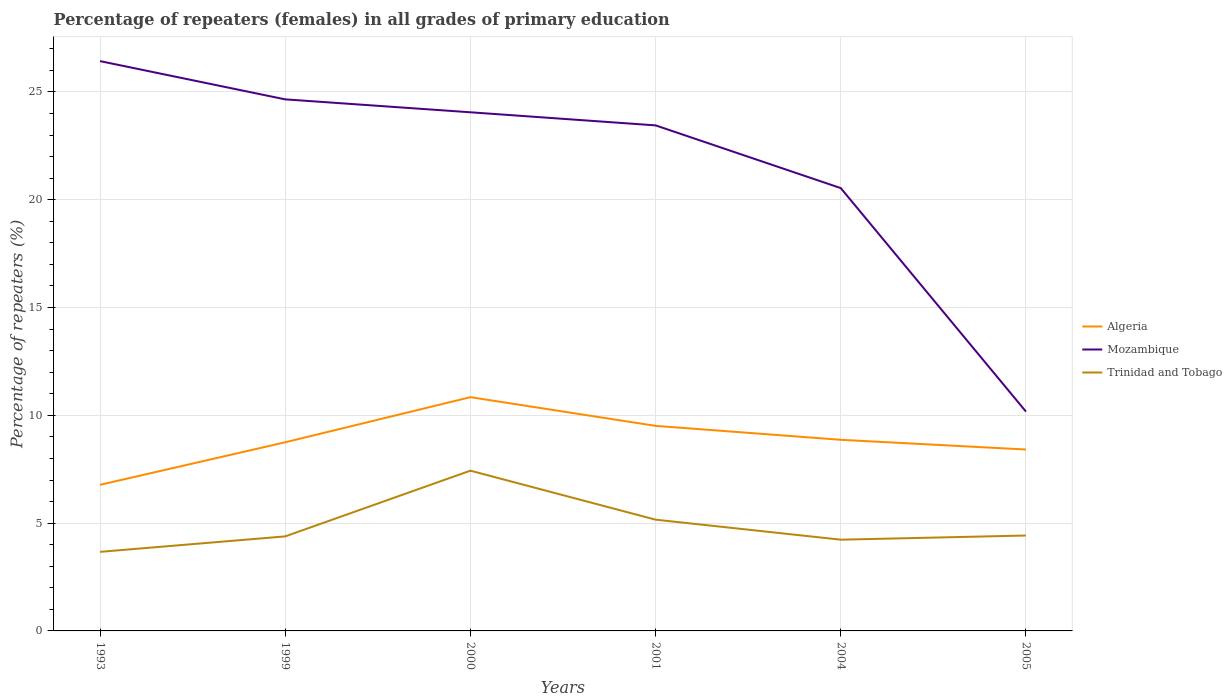Does the line corresponding to Trinidad and Tobago intersect with the line corresponding to Mozambique?
Make the answer very short. No. Is the number of lines equal to the number of legend labels?
Give a very brief answer. Yes. Across all years, what is the maximum percentage of repeaters (females) in Algeria?
Give a very brief answer. 6.78. What is the total percentage of repeaters (females) in Trinidad and Tobago in the graph?
Provide a short and direct response. 0.15. What is the difference between the highest and the second highest percentage of repeaters (females) in Mozambique?
Your answer should be compact. 16.26. What is the difference between the highest and the lowest percentage of repeaters (females) in Algeria?
Make the answer very short. 3. Are the values on the major ticks of Y-axis written in scientific E-notation?
Make the answer very short. No. How are the legend labels stacked?
Provide a succinct answer. Vertical. What is the title of the graph?
Your response must be concise. Percentage of repeaters (females) in all grades of primary education. Does "Angola" appear as one of the legend labels in the graph?
Your answer should be compact. No. What is the label or title of the Y-axis?
Offer a terse response. Percentage of repeaters (%). What is the Percentage of repeaters (%) in Algeria in 1993?
Provide a short and direct response. 6.78. What is the Percentage of repeaters (%) in Mozambique in 1993?
Your response must be concise. 26.43. What is the Percentage of repeaters (%) of Trinidad and Tobago in 1993?
Keep it short and to the point. 3.67. What is the Percentage of repeaters (%) in Algeria in 1999?
Offer a terse response. 8.75. What is the Percentage of repeaters (%) in Mozambique in 1999?
Your answer should be very brief. 24.65. What is the Percentage of repeaters (%) in Trinidad and Tobago in 1999?
Offer a very short reply. 4.38. What is the Percentage of repeaters (%) of Algeria in 2000?
Make the answer very short. 10.84. What is the Percentage of repeaters (%) in Mozambique in 2000?
Your answer should be compact. 24.06. What is the Percentage of repeaters (%) in Trinidad and Tobago in 2000?
Your answer should be very brief. 7.43. What is the Percentage of repeaters (%) in Algeria in 2001?
Your answer should be compact. 9.51. What is the Percentage of repeaters (%) of Mozambique in 2001?
Offer a very short reply. 23.45. What is the Percentage of repeaters (%) in Trinidad and Tobago in 2001?
Offer a very short reply. 5.16. What is the Percentage of repeaters (%) in Algeria in 2004?
Your answer should be compact. 8.86. What is the Percentage of repeaters (%) in Mozambique in 2004?
Ensure brevity in your answer.  20.54. What is the Percentage of repeaters (%) of Trinidad and Tobago in 2004?
Your answer should be compact. 4.23. What is the Percentage of repeaters (%) in Algeria in 2005?
Offer a terse response. 8.41. What is the Percentage of repeaters (%) in Mozambique in 2005?
Your response must be concise. 10.17. What is the Percentage of repeaters (%) of Trinidad and Tobago in 2005?
Your response must be concise. 4.43. Across all years, what is the maximum Percentage of repeaters (%) in Algeria?
Provide a short and direct response. 10.84. Across all years, what is the maximum Percentage of repeaters (%) in Mozambique?
Offer a very short reply. 26.43. Across all years, what is the maximum Percentage of repeaters (%) of Trinidad and Tobago?
Provide a short and direct response. 7.43. Across all years, what is the minimum Percentage of repeaters (%) in Algeria?
Ensure brevity in your answer.  6.78. Across all years, what is the minimum Percentage of repeaters (%) in Mozambique?
Make the answer very short. 10.17. Across all years, what is the minimum Percentage of repeaters (%) in Trinidad and Tobago?
Make the answer very short. 3.67. What is the total Percentage of repeaters (%) of Algeria in the graph?
Offer a very short reply. 53.16. What is the total Percentage of repeaters (%) of Mozambique in the graph?
Your response must be concise. 129.3. What is the total Percentage of repeaters (%) of Trinidad and Tobago in the graph?
Ensure brevity in your answer.  29.3. What is the difference between the Percentage of repeaters (%) of Algeria in 1993 and that in 1999?
Provide a succinct answer. -1.97. What is the difference between the Percentage of repeaters (%) of Mozambique in 1993 and that in 1999?
Offer a very short reply. 1.77. What is the difference between the Percentage of repeaters (%) in Trinidad and Tobago in 1993 and that in 1999?
Keep it short and to the point. -0.72. What is the difference between the Percentage of repeaters (%) of Algeria in 1993 and that in 2000?
Offer a very short reply. -4.07. What is the difference between the Percentage of repeaters (%) of Mozambique in 1993 and that in 2000?
Provide a short and direct response. 2.37. What is the difference between the Percentage of repeaters (%) of Trinidad and Tobago in 1993 and that in 2000?
Give a very brief answer. -3.77. What is the difference between the Percentage of repeaters (%) in Algeria in 1993 and that in 2001?
Offer a very short reply. -2.73. What is the difference between the Percentage of repeaters (%) of Mozambique in 1993 and that in 2001?
Keep it short and to the point. 2.98. What is the difference between the Percentage of repeaters (%) of Trinidad and Tobago in 1993 and that in 2001?
Offer a very short reply. -1.49. What is the difference between the Percentage of repeaters (%) in Algeria in 1993 and that in 2004?
Your answer should be compact. -2.09. What is the difference between the Percentage of repeaters (%) in Mozambique in 1993 and that in 2004?
Your answer should be very brief. 5.89. What is the difference between the Percentage of repeaters (%) in Trinidad and Tobago in 1993 and that in 2004?
Keep it short and to the point. -0.56. What is the difference between the Percentage of repeaters (%) in Algeria in 1993 and that in 2005?
Your answer should be compact. -1.64. What is the difference between the Percentage of repeaters (%) in Mozambique in 1993 and that in 2005?
Offer a terse response. 16.26. What is the difference between the Percentage of repeaters (%) of Trinidad and Tobago in 1993 and that in 2005?
Provide a succinct answer. -0.76. What is the difference between the Percentage of repeaters (%) of Algeria in 1999 and that in 2000?
Give a very brief answer. -2.09. What is the difference between the Percentage of repeaters (%) of Mozambique in 1999 and that in 2000?
Ensure brevity in your answer.  0.6. What is the difference between the Percentage of repeaters (%) in Trinidad and Tobago in 1999 and that in 2000?
Keep it short and to the point. -3.05. What is the difference between the Percentage of repeaters (%) of Algeria in 1999 and that in 2001?
Give a very brief answer. -0.76. What is the difference between the Percentage of repeaters (%) of Mozambique in 1999 and that in 2001?
Ensure brevity in your answer.  1.21. What is the difference between the Percentage of repeaters (%) in Trinidad and Tobago in 1999 and that in 2001?
Your answer should be very brief. -0.78. What is the difference between the Percentage of repeaters (%) in Algeria in 1999 and that in 2004?
Make the answer very short. -0.11. What is the difference between the Percentage of repeaters (%) of Mozambique in 1999 and that in 2004?
Ensure brevity in your answer.  4.12. What is the difference between the Percentage of repeaters (%) in Trinidad and Tobago in 1999 and that in 2004?
Keep it short and to the point. 0.15. What is the difference between the Percentage of repeaters (%) in Algeria in 1999 and that in 2005?
Ensure brevity in your answer.  0.34. What is the difference between the Percentage of repeaters (%) of Mozambique in 1999 and that in 2005?
Provide a short and direct response. 14.48. What is the difference between the Percentage of repeaters (%) in Trinidad and Tobago in 1999 and that in 2005?
Give a very brief answer. -0.04. What is the difference between the Percentage of repeaters (%) in Algeria in 2000 and that in 2001?
Give a very brief answer. 1.33. What is the difference between the Percentage of repeaters (%) in Mozambique in 2000 and that in 2001?
Give a very brief answer. 0.61. What is the difference between the Percentage of repeaters (%) of Trinidad and Tobago in 2000 and that in 2001?
Ensure brevity in your answer.  2.27. What is the difference between the Percentage of repeaters (%) in Algeria in 2000 and that in 2004?
Offer a terse response. 1.98. What is the difference between the Percentage of repeaters (%) of Mozambique in 2000 and that in 2004?
Ensure brevity in your answer.  3.52. What is the difference between the Percentage of repeaters (%) of Trinidad and Tobago in 2000 and that in 2004?
Ensure brevity in your answer.  3.2. What is the difference between the Percentage of repeaters (%) of Algeria in 2000 and that in 2005?
Keep it short and to the point. 2.43. What is the difference between the Percentage of repeaters (%) in Mozambique in 2000 and that in 2005?
Your answer should be very brief. 13.88. What is the difference between the Percentage of repeaters (%) of Trinidad and Tobago in 2000 and that in 2005?
Offer a terse response. 3.01. What is the difference between the Percentage of repeaters (%) of Algeria in 2001 and that in 2004?
Your response must be concise. 0.65. What is the difference between the Percentage of repeaters (%) of Mozambique in 2001 and that in 2004?
Your answer should be very brief. 2.91. What is the difference between the Percentage of repeaters (%) of Trinidad and Tobago in 2001 and that in 2004?
Your response must be concise. 0.93. What is the difference between the Percentage of repeaters (%) of Algeria in 2001 and that in 2005?
Provide a short and direct response. 1.1. What is the difference between the Percentage of repeaters (%) of Mozambique in 2001 and that in 2005?
Your answer should be compact. 13.28. What is the difference between the Percentage of repeaters (%) of Trinidad and Tobago in 2001 and that in 2005?
Provide a succinct answer. 0.73. What is the difference between the Percentage of repeaters (%) in Algeria in 2004 and that in 2005?
Your response must be concise. 0.45. What is the difference between the Percentage of repeaters (%) in Mozambique in 2004 and that in 2005?
Your answer should be very brief. 10.37. What is the difference between the Percentage of repeaters (%) of Trinidad and Tobago in 2004 and that in 2005?
Provide a short and direct response. -0.19. What is the difference between the Percentage of repeaters (%) of Algeria in 1993 and the Percentage of repeaters (%) of Mozambique in 1999?
Your answer should be very brief. -17.88. What is the difference between the Percentage of repeaters (%) of Algeria in 1993 and the Percentage of repeaters (%) of Trinidad and Tobago in 1999?
Ensure brevity in your answer.  2.39. What is the difference between the Percentage of repeaters (%) of Mozambique in 1993 and the Percentage of repeaters (%) of Trinidad and Tobago in 1999?
Keep it short and to the point. 22.04. What is the difference between the Percentage of repeaters (%) in Algeria in 1993 and the Percentage of repeaters (%) in Mozambique in 2000?
Your response must be concise. -17.28. What is the difference between the Percentage of repeaters (%) of Algeria in 1993 and the Percentage of repeaters (%) of Trinidad and Tobago in 2000?
Your answer should be compact. -0.66. What is the difference between the Percentage of repeaters (%) in Mozambique in 1993 and the Percentage of repeaters (%) in Trinidad and Tobago in 2000?
Give a very brief answer. 19. What is the difference between the Percentage of repeaters (%) in Algeria in 1993 and the Percentage of repeaters (%) in Mozambique in 2001?
Keep it short and to the point. -16.67. What is the difference between the Percentage of repeaters (%) in Algeria in 1993 and the Percentage of repeaters (%) in Trinidad and Tobago in 2001?
Your response must be concise. 1.62. What is the difference between the Percentage of repeaters (%) in Mozambique in 1993 and the Percentage of repeaters (%) in Trinidad and Tobago in 2001?
Offer a terse response. 21.27. What is the difference between the Percentage of repeaters (%) in Algeria in 1993 and the Percentage of repeaters (%) in Mozambique in 2004?
Offer a very short reply. -13.76. What is the difference between the Percentage of repeaters (%) in Algeria in 1993 and the Percentage of repeaters (%) in Trinidad and Tobago in 2004?
Give a very brief answer. 2.54. What is the difference between the Percentage of repeaters (%) in Mozambique in 1993 and the Percentage of repeaters (%) in Trinidad and Tobago in 2004?
Your response must be concise. 22.2. What is the difference between the Percentage of repeaters (%) of Algeria in 1993 and the Percentage of repeaters (%) of Mozambique in 2005?
Offer a very short reply. -3.4. What is the difference between the Percentage of repeaters (%) in Algeria in 1993 and the Percentage of repeaters (%) in Trinidad and Tobago in 2005?
Offer a terse response. 2.35. What is the difference between the Percentage of repeaters (%) in Mozambique in 1993 and the Percentage of repeaters (%) in Trinidad and Tobago in 2005?
Offer a very short reply. 22. What is the difference between the Percentage of repeaters (%) of Algeria in 1999 and the Percentage of repeaters (%) of Mozambique in 2000?
Provide a short and direct response. -15.31. What is the difference between the Percentage of repeaters (%) in Algeria in 1999 and the Percentage of repeaters (%) in Trinidad and Tobago in 2000?
Keep it short and to the point. 1.32. What is the difference between the Percentage of repeaters (%) of Mozambique in 1999 and the Percentage of repeaters (%) of Trinidad and Tobago in 2000?
Ensure brevity in your answer.  17.22. What is the difference between the Percentage of repeaters (%) of Algeria in 1999 and the Percentage of repeaters (%) of Mozambique in 2001?
Your answer should be compact. -14.7. What is the difference between the Percentage of repeaters (%) of Algeria in 1999 and the Percentage of repeaters (%) of Trinidad and Tobago in 2001?
Provide a short and direct response. 3.59. What is the difference between the Percentage of repeaters (%) in Mozambique in 1999 and the Percentage of repeaters (%) in Trinidad and Tobago in 2001?
Provide a short and direct response. 19.49. What is the difference between the Percentage of repeaters (%) of Algeria in 1999 and the Percentage of repeaters (%) of Mozambique in 2004?
Provide a short and direct response. -11.79. What is the difference between the Percentage of repeaters (%) of Algeria in 1999 and the Percentage of repeaters (%) of Trinidad and Tobago in 2004?
Offer a very short reply. 4.52. What is the difference between the Percentage of repeaters (%) of Mozambique in 1999 and the Percentage of repeaters (%) of Trinidad and Tobago in 2004?
Your answer should be very brief. 20.42. What is the difference between the Percentage of repeaters (%) in Algeria in 1999 and the Percentage of repeaters (%) in Mozambique in 2005?
Provide a short and direct response. -1.42. What is the difference between the Percentage of repeaters (%) in Algeria in 1999 and the Percentage of repeaters (%) in Trinidad and Tobago in 2005?
Keep it short and to the point. 4.32. What is the difference between the Percentage of repeaters (%) in Mozambique in 1999 and the Percentage of repeaters (%) in Trinidad and Tobago in 2005?
Keep it short and to the point. 20.23. What is the difference between the Percentage of repeaters (%) in Algeria in 2000 and the Percentage of repeaters (%) in Mozambique in 2001?
Ensure brevity in your answer.  -12.61. What is the difference between the Percentage of repeaters (%) of Algeria in 2000 and the Percentage of repeaters (%) of Trinidad and Tobago in 2001?
Offer a terse response. 5.68. What is the difference between the Percentage of repeaters (%) in Mozambique in 2000 and the Percentage of repeaters (%) in Trinidad and Tobago in 2001?
Keep it short and to the point. 18.9. What is the difference between the Percentage of repeaters (%) of Algeria in 2000 and the Percentage of repeaters (%) of Mozambique in 2004?
Your answer should be compact. -9.7. What is the difference between the Percentage of repeaters (%) of Algeria in 2000 and the Percentage of repeaters (%) of Trinidad and Tobago in 2004?
Your answer should be compact. 6.61. What is the difference between the Percentage of repeaters (%) in Mozambique in 2000 and the Percentage of repeaters (%) in Trinidad and Tobago in 2004?
Provide a succinct answer. 19.82. What is the difference between the Percentage of repeaters (%) of Algeria in 2000 and the Percentage of repeaters (%) of Mozambique in 2005?
Give a very brief answer. 0.67. What is the difference between the Percentage of repeaters (%) in Algeria in 2000 and the Percentage of repeaters (%) in Trinidad and Tobago in 2005?
Keep it short and to the point. 6.42. What is the difference between the Percentage of repeaters (%) of Mozambique in 2000 and the Percentage of repeaters (%) of Trinidad and Tobago in 2005?
Keep it short and to the point. 19.63. What is the difference between the Percentage of repeaters (%) in Algeria in 2001 and the Percentage of repeaters (%) in Mozambique in 2004?
Your response must be concise. -11.03. What is the difference between the Percentage of repeaters (%) of Algeria in 2001 and the Percentage of repeaters (%) of Trinidad and Tobago in 2004?
Your answer should be compact. 5.28. What is the difference between the Percentage of repeaters (%) of Mozambique in 2001 and the Percentage of repeaters (%) of Trinidad and Tobago in 2004?
Provide a short and direct response. 19.22. What is the difference between the Percentage of repeaters (%) of Algeria in 2001 and the Percentage of repeaters (%) of Mozambique in 2005?
Your response must be concise. -0.66. What is the difference between the Percentage of repeaters (%) in Algeria in 2001 and the Percentage of repeaters (%) in Trinidad and Tobago in 2005?
Your answer should be very brief. 5.09. What is the difference between the Percentage of repeaters (%) of Mozambique in 2001 and the Percentage of repeaters (%) of Trinidad and Tobago in 2005?
Your answer should be compact. 19.02. What is the difference between the Percentage of repeaters (%) of Algeria in 2004 and the Percentage of repeaters (%) of Mozambique in 2005?
Your answer should be compact. -1.31. What is the difference between the Percentage of repeaters (%) of Algeria in 2004 and the Percentage of repeaters (%) of Trinidad and Tobago in 2005?
Provide a short and direct response. 4.44. What is the difference between the Percentage of repeaters (%) of Mozambique in 2004 and the Percentage of repeaters (%) of Trinidad and Tobago in 2005?
Your response must be concise. 16.11. What is the average Percentage of repeaters (%) of Algeria per year?
Offer a very short reply. 8.86. What is the average Percentage of repeaters (%) in Mozambique per year?
Your answer should be compact. 21.55. What is the average Percentage of repeaters (%) in Trinidad and Tobago per year?
Keep it short and to the point. 4.88. In the year 1993, what is the difference between the Percentage of repeaters (%) of Algeria and Percentage of repeaters (%) of Mozambique?
Ensure brevity in your answer.  -19.65. In the year 1993, what is the difference between the Percentage of repeaters (%) in Algeria and Percentage of repeaters (%) in Trinidad and Tobago?
Offer a terse response. 3.11. In the year 1993, what is the difference between the Percentage of repeaters (%) of Mozambique and Percentage of repeaters (%) of Trinidad and Tobago?
Your response must be concise. 22.76. In the year 1999, what is the difference between the Percentage of repeaters (%) in Algeria and Percentage of repeaters (%) in Mozambique?
Ensure brevity in your answer.  -15.9. In the year 1999, what is the difference between the Percentage of repeaters (%) in Algeria and Percentage of repeaters (%) in Trinidad and Tobago?
Your answer should be compact. 4.37. In the year 1999, what is the difference between the Percentage of repeaters (%) in Mozambique and Percentage of repeaters (%) in Trinidad and Tobago?
Your response must be concise. 20.27. In the year 2000, what is the difference between the Percentage of repeaters (%) in Algeria and Percentage of repeaters (%) in Mozambique?
Keep it short and to the point. -13.21. In the year 2000, what is the difference between the Percentage of repeaters (%) in Algeria and Percentage of repeaters (%) in Trinidad and Tobago?
Ensure brevity in your answer.  3.41. In the year 2000, what is the difference between the Percentage of repeaters (%) of Mozambique and Percentage of repeaters (%) of Trinidad and Tobago?
Your answer should be compact. 16.62. In the year 2001, what is the difference between the Percentage of repeaters (%) in Algeria and Percentage of repeaters (%) in Mozambique?
Offer a terse response. -13.94. In the year 2001, what is the difference between the Percentage of repeaters (%) in Algeria and Percentage of repeaters (%) in Trinidad and Tobago?
Your answer should be very brief. 4.35. In the year 2001, what is the difference between the Percentage of repeaters (%) in Mozambique and Percentage of repeaters (%) in Trinidad and Tobago?
Make the answer very short. 18.29. In the year 2004, what is the difference between the Percentage of repeaters (%) of Algeria and Percentage of repeaters (%) of Mozambique?
Your answer should be very brief. -11.67. In the year 2004, what is the difference between the Percentage of repeaters (%) in Algeria and Percentage of repeaters (%) in Trinidad and Tobago?
Ensure brevity in your answer.  4.63. In the year 2004, what is the difference between the Percentage of repeaters (%) of Mozambique and Percentage of repeaters (%) of Trinidad and Tobago?
Provide a succinct answer. 16.31. In the year 2005, what is the difference between the Percentage of repeaters (%) of Algeria and Percentage of repeaters (%) of Mozambique?
Ensure brevity in your answer.  -1.76. In the year 2005, what is the difference between the Percentage of repeaters (%) of Algeria and Percentage of repeaters (%) of Trinidad and Tobago?
Make the answer very short. 3.99. In the year 2005, what is the difference between the Percentage of repeaters (%) of Mozambique and Percentage of repeaters (%) of Trinidad and Tobago?
Provide a short and direct response. 5.75. What is the ratio of the Percentage of repeaters (%) of Algeria in 1993 to that in 1999?
Provide a succinct answer. 0.77. What is the ratio of the Percentage of repeaters (%) of Mozambique in 1993 to that in 1999?
Give a very brief answer. 1.07. What is the ratio of the Percentage of repeaters (%) of Trinidad and Tobago in 1993 to that in 1999?
Offer a very short reply. 0.84. What is the ratio of the Percentage of repeaters (%) of Mozambique in 1993 to that in 2000?
Your response must be concise. 1.1. What is the ratio of the Percentage of repeaters (%) of Trinidad and Tobago in 1993 to that in 2000?
Your response must be concise. 0.49. What is the ratio of the Percentage of repeaters (%) in Algeria in 1993 to that in 2001?
Ensure brevity in your answer.  0.71. What is the ratio of the Percentage of repeaters (%) of Mozambique in 1993 to that in 2001?
Make the answer very short. 1.13. What is the ratio of the Percentage of repeaters (%) in Trinidad and Tobago in 1993 to that in 2001?
Keep it short and to the point. 0.71. What is the ratio of the Percentage of repeaters (%) in Algeria in 1993 to that in 2004?
Offer a terse response. 0.76. What is the ratio of the Percentage of repeaters (%) in Mozambique in 1993 to that in 2004?
Offer a terse response. 1.29. What is the ratio of the Percentage of repeaters (%) of Trinidad and Tobago in 1993 to that in 2004?
Your response must be concise. 0.87. What is the ratio of the Percentage of repeaters (%) of Algeria in 1993 to that in 2005?
Your answer should be very brief. 0.81. What is the ratio of the Percentage of repeaters (%) of Mozambique in 1993 to that in 2005?
Your response must be concise. 2.6. What is the ratio of the Percentage of repeaters (%) in Trinidad and Tobago in 1993 to that in 2005?
Your answer should be compact. 0.83. What is the ratio of the Percentage of repeaters (%) of Algeria in 1999 to that in 2000?
Offer a very short reply. 0.81. What is the ratio of the Percentage of repeaters (%) of Mozambique in 1999 to that in 2000?
Give a very brief answer. 1.02. What is the ratio of the Percentage of repeaters (%) in Trinidad and Tobago in 1999 to that in 2000?
Ensure brevity in your answer.  0.59. What is the ratio of the Percentage of repeaters (%) of Algeria in 1999 to that in 2001?
Offer a very short reply. 0.92. What is the ratio of the Percentage of repeaters (%) of Mozambique in 1999 to that in 2001?
Your answer should be very brief. 1.05. What is the ratio of the Percentage of repeaters (%) in Trinidad and Tobago in 1999 to that in 2001?
Your response must be concise. 0.85. What is the ratio of the Percentage of repeaters (%) in Algeria in 1999 to that in 2004?
Provide a succinct answer. 0.99. What is the ratio of the Percentage of repeaters (%) of Mozambique in 1999 to that in 2004?
Ensure brevity in your answer.  1.2. What is the ratio of the Percentage of repeaters (%) in Trinidad and Tobago in 1999 to that in 2004?
Offer a terse response. 1.04. What is the ratio of the Percentage of repeaters (%) in Algeria in 1999 to that in 2005?
Offer a terse response. 1.04. What is the ratio of the Percentage of repeaters (%) of Mozambique in 1999 to that in 2005?
Your answer should be compact. 2.42. What is the ratio of the Percentage of repeaters (%) of Trinidad and Tobago in 1999 to that in 2005?
Offer a terse response. 0.99. What is the ratio of the Percentage of repeaters (%) of Algeria in 2000 to that in 2001?
Offer a terse response. 1.14. What is the ratio of the Percentage of repeaters (%) of Mozambique in 2000 to that in 2001?
Make the answer very short. 1.03. What is the ratio of the Percentage of repeaters (%) of Trinidad and Tobago in 2000 to that in 2001?
Offer a very short reply. 1.44. What is the ratio of the Percentage of repeaters (%) in Algeria in 2000 to that in 2004?
Offer a terse response. 1.22. What is the ratio of the Percentage of repeaters (%) in Mozambique in 2000 to that in 2004?
Make the answer very short. 1.17. What is the ratio of the Percentage of repeaters (%) of Trinidad and Tobago in 2000 to that in 2004?
Ensure brevity in your answer.  1.76. What is the ratio of the Percentage of repeaters (%) in Algeria in 2000 to that in 2005?
Your answer should be very brief. 1.29. What is the ratio of the Percentage of repeaters (%) of Mozambique in 2000 to that in 2005?
Your answer should be compact. 2.36. What is the ratio of the Percentage of repeaters (%) in Trinidad and Tobago in 2000 to that in 2005?
Your answer should be compact. 1.68. What is the ratio of the Percentage of repeaters (%) of Algeria in 2001 to that in 2004?
Make the answer very short. 1.07. What is the ratio of the Percentage of repeaters (%) of Mozambique in 2001 to that in 2004?
Provide a short and direct response. 1.14. What is the ratio of the Percentage of repeaters (%) in Trinidad and Tobago in 2001 to that in 2004?
Give a very brief answer. 1.22. What is the ratio of the Percentage of repeaters (%) in Algeria in 2001 to that in 2005?
Keep it short and to the point. 1.13. What is the ratio of the Percentage of repeaters (%) of Mozambique in 2001 to that in 2005?
Provide a succinct answer. 2.31. What is the ratio of the Percentage of repeaters (%) of Trinidad and Tobago in 2001 to that in 2005?
Provide a succinct answer. 1.17. What is the ratio of the Percentage of repeaters (%) in Algeria in 2004 to that in 2005?
Your answer should be very brief. 1.05. What is the ratio of the Percentage of repeaters (%) of Mozambique in 2004 to that in 2005?
Your answer should be very brief. 2.02. What is the ratio of the Percentage of repeaters (%) of Trinidad and Tobago in 2004 to that in 2005?
Give a very brief answer. 0.96. What is the difference between the highest and the second highest Percentage of repeaters (%) of Algeria?
Ensure brevity in your answer.  1.33. What is the difference between the highest and the second highest Percentage of repeaters (%) of Mozambique?
Your response must be concise. 1.77. What is the difference between the highest and the second highest Percentage of repeaters (%) in Trinidad and Tobago?
Provide a succinct answer. 2.27. What is the difference between the highest and the lowest Percentage of repeaters (%) of Algeria?
Your answer should be very brief. 4.07. What is the difference between the highest and the lowest Percentage of repeaters (%) of Mozambique?
Ensure brevity in your answer.  16.26. What is the difference between the highest and the lowest Percentage of repeaters (%) of Trinidad and Tobago?
Your answer should be compact. 3.77. 